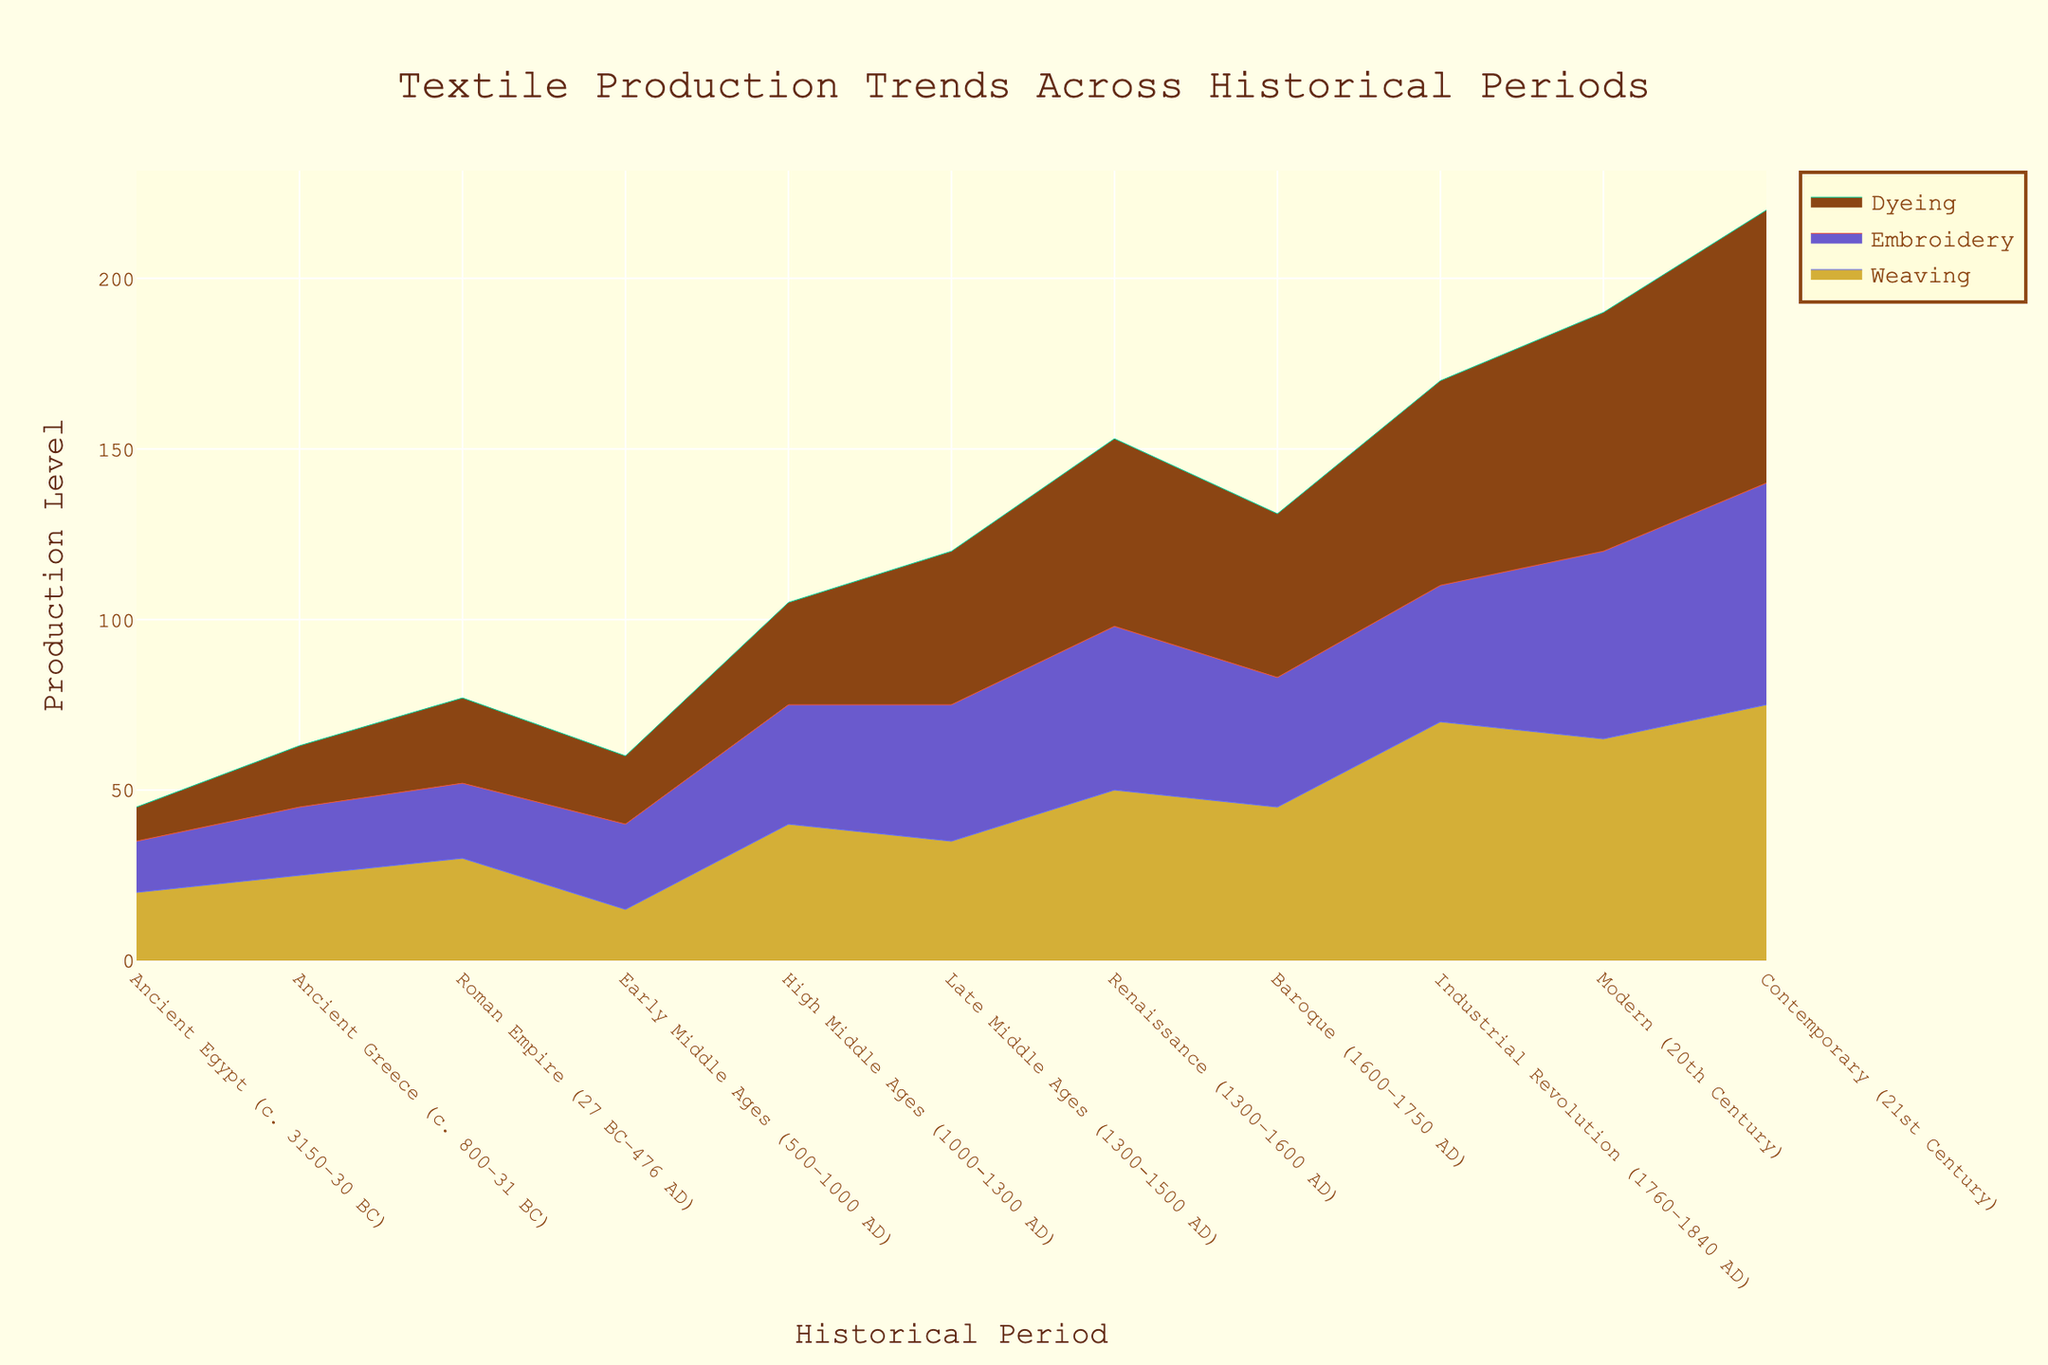What is the title of the figure? The title is usually placed at the top of the figure and is the largest text. From the description, the title of the figure is "Textile Production Trends Across Historical Periods".
Answer: Textile Production Trends Across Historical Periods Which technique had the highest production level in the Renaissance period? To find this, look at the Renaissance period and compare the heights of the different techniques. The highest value is for Dyeing.
Answer: Dyeing Which historical period shows the highest production in Weaving? To determine this, look across all periods and identify the one with the maximum height for Weaving. The Contemporary (21st Century) period has the highest Weaving production.
Answer: Contemporary (21st Century) In which period did Embroidery production surpass Weaving production? Compare the values of Embroidery and Weaving for each period. The Early Middle Ages (500–1000 AD) is the period where Embroidery production surpasses Weaving production.
Answer: Early Middle Ages (500–1000 AD) What is the difference in Dyeing production between the Roman Empire and the Industrial Revolution periods? Subtract the Dyeing production value for the Roman Empire (25) from that of the Industrial Revolution (60). The difference is 60 - 25 = 35.
Answer: 35 What happens to the production trends of all three techniques during the Industrial Revolution? Examine the trends in the Industrial Revolution period. All three techniques see a significant increase in production levels.
Answer: Increase During which period was the production of Embroidery the highest? Identify the period with the tallest section for Embroidery. The Renaissance period has the highest production of Embroidery.
Answer: Renaissance Which two periods have a close Weaving production value, and what is the difference? Compare the Weaving values to find two periods where the values are close. Both Baroque (45) and Late Middle Ages (35) are close, with a difference of 10.
Answer: Baroque and Late Middle Ages, 10 How does the production of Dyeing change from Ancient Greece to the Modern period? Look at the Dyeing values for Ancient Greece (18) and the Modern period (70). Dyeing production increases significantly from Ancient Greece to the Modern period.
Answer: Increases What is the total production of Embroidery during the High Middle Ages and Renaissance periods? Sum the production values of Embroidery for both High Middle Ages (35) and Renaissance (48). 35 + 48 = 83.
Answer: 83 